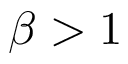<formula> <loc_0><loc_0><loc_500><loc_500>\beta > 1</formula> 